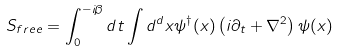Convert formula to latex. <formula><loc_0><loc_0><loc_500><loc_500>S _ { f r e e } = \int ^ { - i \beta } _ { 0 } d t \int d ^ { d } x \psi ^ { \dagger } ( { x } ) \left ( i \partial _ { t } + \nabla ^ { 2 } \right ) \psi ( { x } )</formula> 